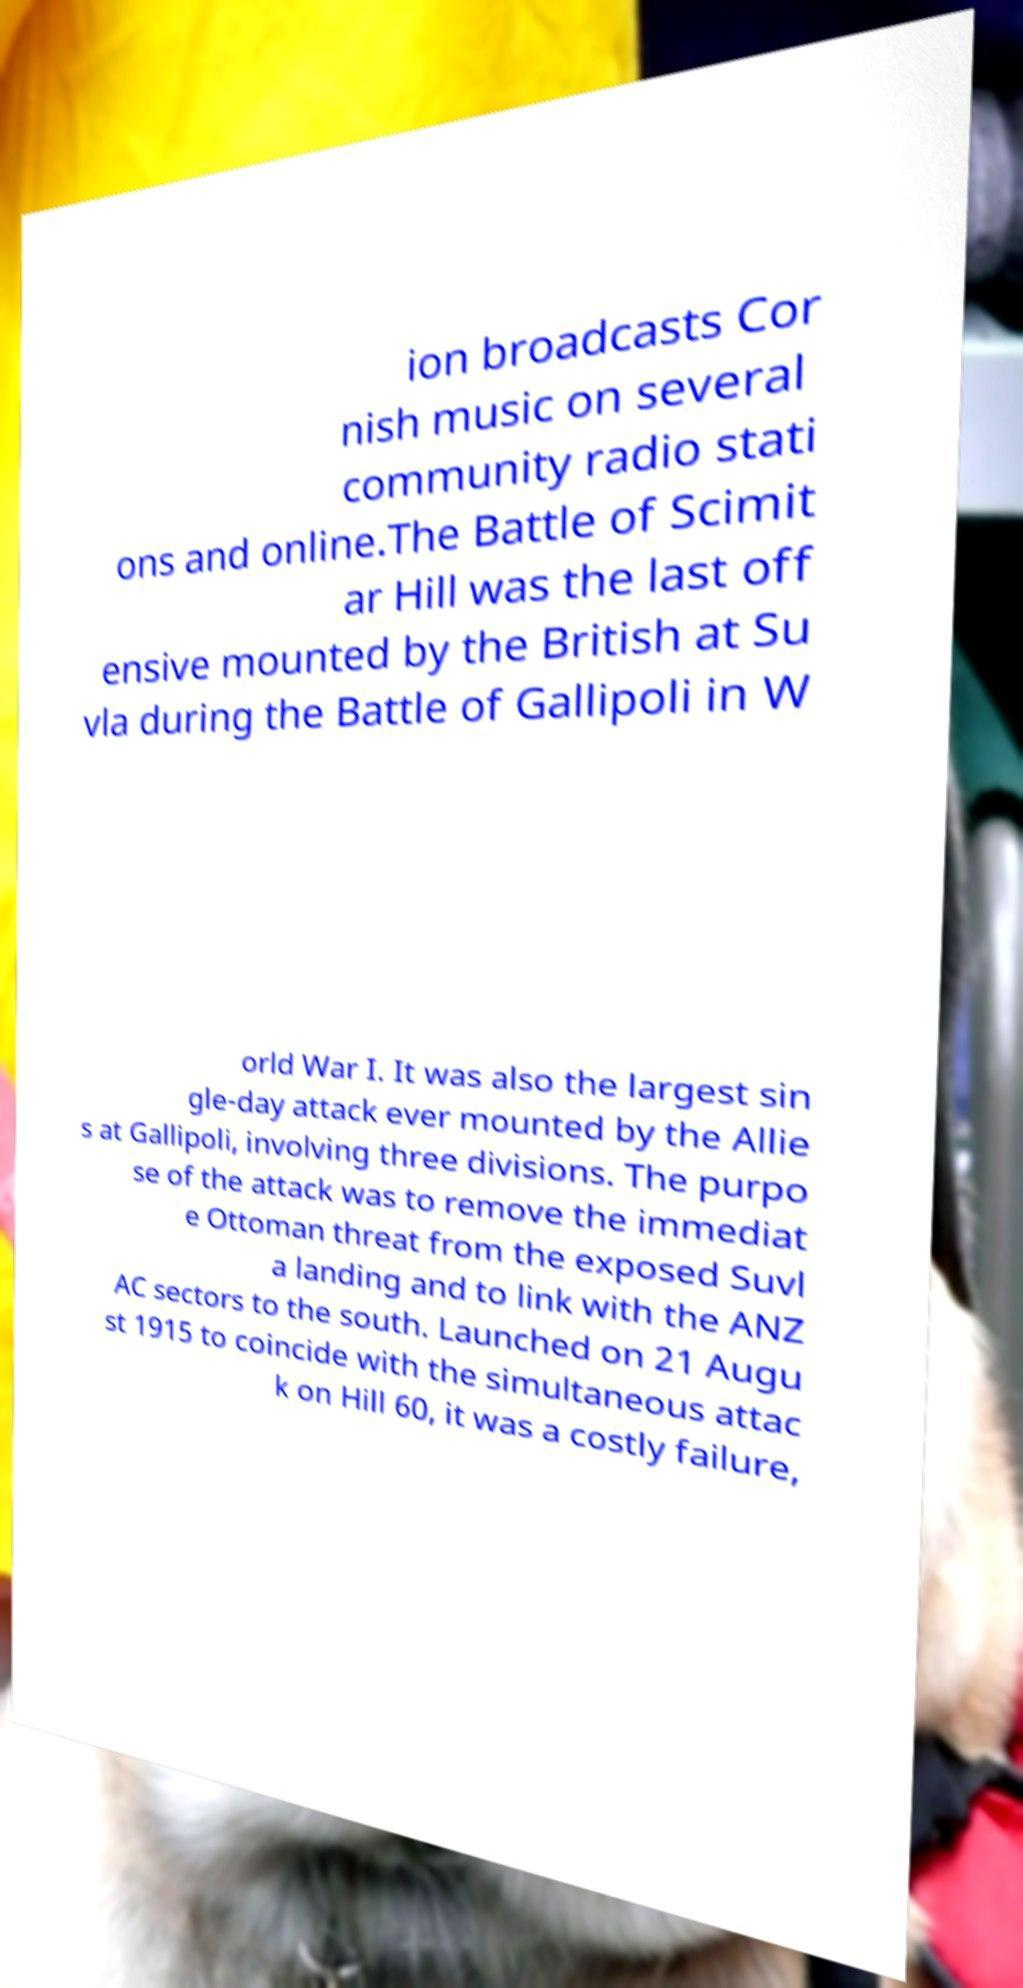Could you extract and type out the text from this image? ion broadcasts Cor nish music on several community radio stati ons and online.The Battle of Scimit ar Hill was the last off ensive mounted by the British at Su vla during the Battle of Gallipoli in W orld War I. It was also the largest sin gle-day attack ever mounted by the Allie s at Gallipoli, involving three divisions. The purpo se of the attack was to remove the immediat e Ottoman threat from the exposed Suvl a landing and to link with the ANZ AC sectors to the south. Launched on 21 Augu st 1915 to coincide with the simultaneous attac k on Hill 60, it was a costly failure, 